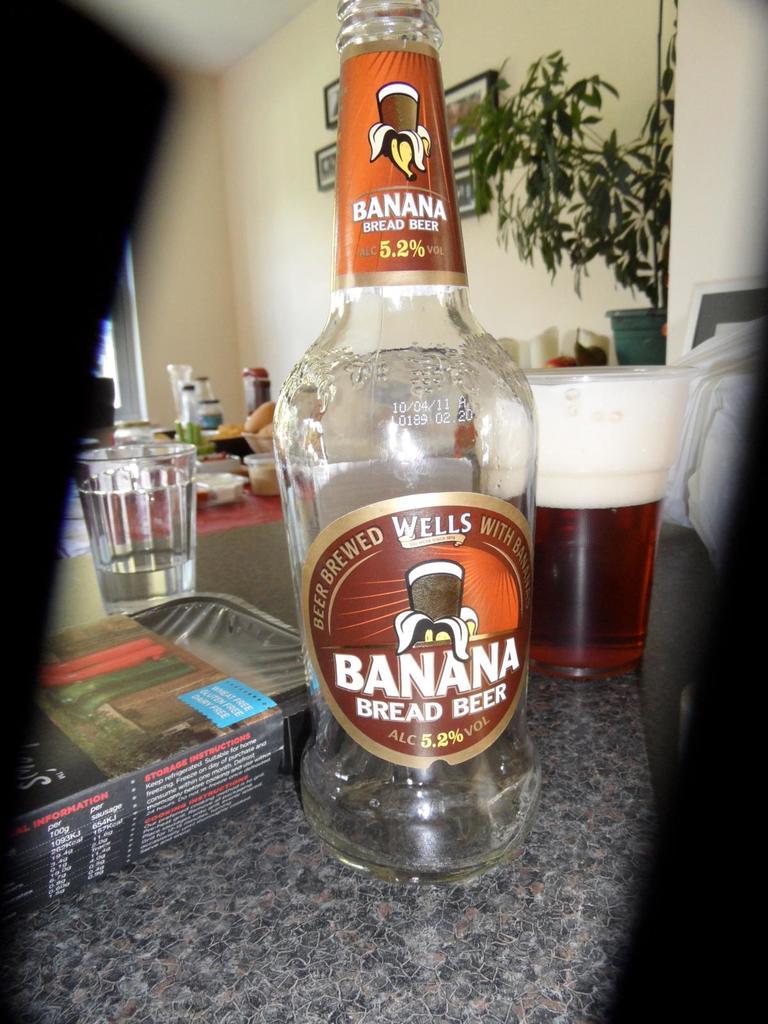What flavor is the beer ?
Your answer should be compact. Banana bread. What percent alcohol does this beer contain?
Ensure brevity in your answer.  5.2%. 